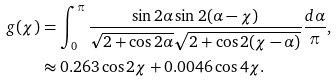<formula> <loc_0><loc_0><loc_500><loc_500>g ( \chi ) & = \int _ { 0 } ^ { \pi } \frac { \sin 2 \alpha \sin 2 ( \alpha - \chi ) } { \sqrt { 2 + \cos 2 \alpha } \sqrt { 2 + \cos 2 ( \chi - \alpha ) } } \frac { d \alpha } { \pi } , \\ & \approx 0 . 2 6 3 \cos 2 \chi + 0 . 0 0 4 6 \cos 4 \chi .</formula> 